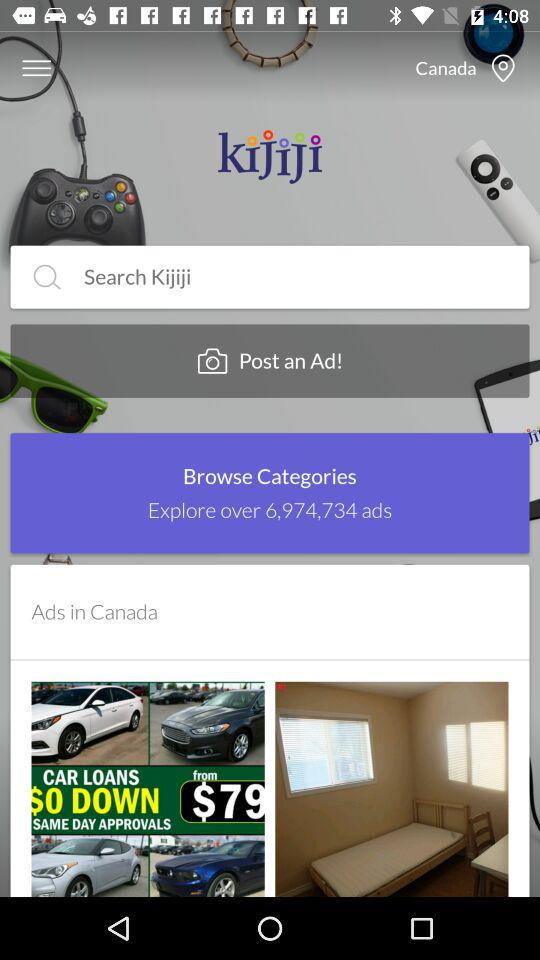What is the name of the application? The name of the application is "Kijiji". 